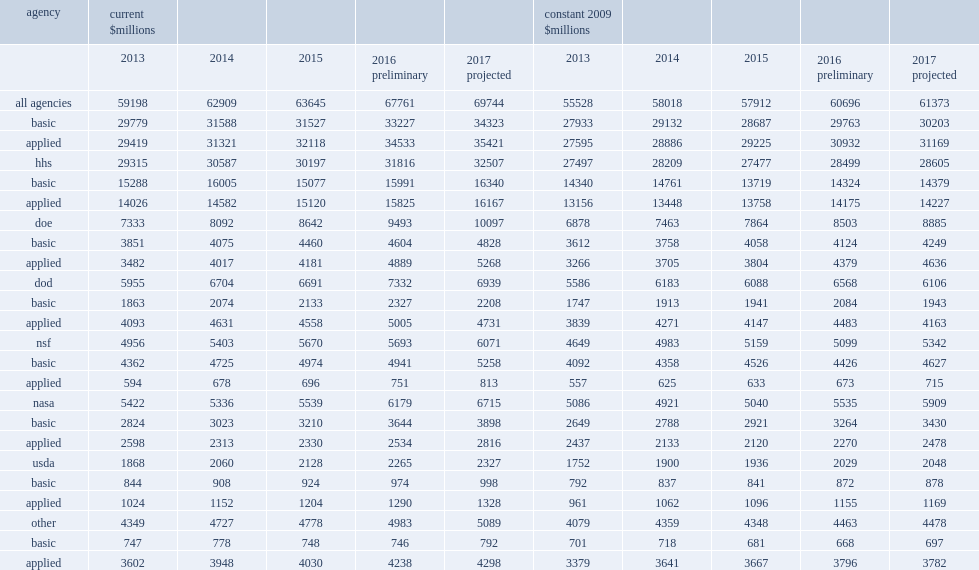Help me parse the entirety of this table. {'header': ['agency', 'current $millions', '', '', '', '', 'constant 2009 $millions', '', '', '', ''], 'rows': [['', '2013', '2014', '2015', '2016 preliminary', '2017 projected', '2013', '2014', '2015', '2016 preliminary', '2017 projected'], ['all agencies', '59198', '62909', '63645', '67761', '69744', '55528', '58018', '57912', '60696', '61373'], ['basic', '29779', '31588', '31527', '33227', '34323', '27933', '29132', '28687', '29763', '30203'], ['applied', '29419', '31321', '32118', '34533', '35421', '27595', '28886', '29225', '30932', '31169'], ['hhs', '29315', '30587', '30197', '31816', '32507', '27497', '28209', '27477', '28499', '28605'], ['basic', '15288', '16005', '15077', '15991', '16340', '14340', '14761', '13719', '14324', '14379'], ['applied', '14026', '14582', '15120', '15825', '16167', '13156', '13448', '13758', '14175', '14227'], ['doe', '7333', '8092', '8642', '9493', '10097', '6878', '7463', '7864', '8503', '8885'], ['basic', '3851', '4075', '4460', '4604', '4828', '3612', '3758', '4058', '4124', '4249'], ['applied', '3482', '4017', '4181', '4889', '5268', '3266', '3705', '3804', '4379', '4636'], ['dod', '5955', '6704', '6691', '7332', '6939', '5586', '6183', '6088', '6568', '6106'], ['basic', '1863', '2074', '2133', '2327', '2208', '1747', '1913', '1941', '2084', '1943'], ['applied', '4093', '4631', '4558', '5005', '4731', '3839', '4271', '4147', '4483', '4163'], ['nsf', '4956', '5403', '5670', '5693', '6071', '4649', '4983', '5159', '5099', '5342'], ['basic', '4362', '4725', '4974', '4941', '5258', '4092', '4358', '4526', '4426', '4627'], ['applied', '594', '678', '696', '751', '813', '557', '625', '633', '673', '715'], ['nasa', '5422', '5336', '5539', '6179', '6715', '5086', '4921', '5040', '5535', '5909'], ['basic', '2824', '3023', '3210', '3644', '3898', '2649', '2788', '2921', '3264', '3430'], ['applied', '2598', '2313', '2330', '2534', '2816', '2437', '2133', '2120', '2270', '2478'], ['usda', '1868', '2060', '2128', '2265', '2327', '1752', '1900', '1936', '2029', '2048'], ['basic', '844', '908', '924', '974', '998', '792', '837', '841', '872', '878'], ['applied', '1024', '1152', '1204', '1290', '1328', '961', '1062', '1096', '1155', '1169'], ['other', '4349', '4727', '4778', '4983', '5089', '4079', '4359', '4348', '4463', '4478'], ['basic', '747', '778', '748', '746', '792', '701', '718', '681', '668', '697'], ['applied', '3602', '3948', '4030', '4238', '4298', '3379', '3641', '3667', '3796', '3782']]} How many million dollars was research funding estimated to increase by in fy 2016? 4116. How many million dollars was research funding estimated to increase to in fy 2016? 67761.0. How many million dollars was research funding projected to increase by in fy 2017? 1983. How many million dollars was research funding was projected to increase to in fy 2017? 69744.0. What was the dod's share of total fy 2015 federal funding for research? 0.10513. What was the dod's share of total fy 2015 federal funding for research? 6691.0. 